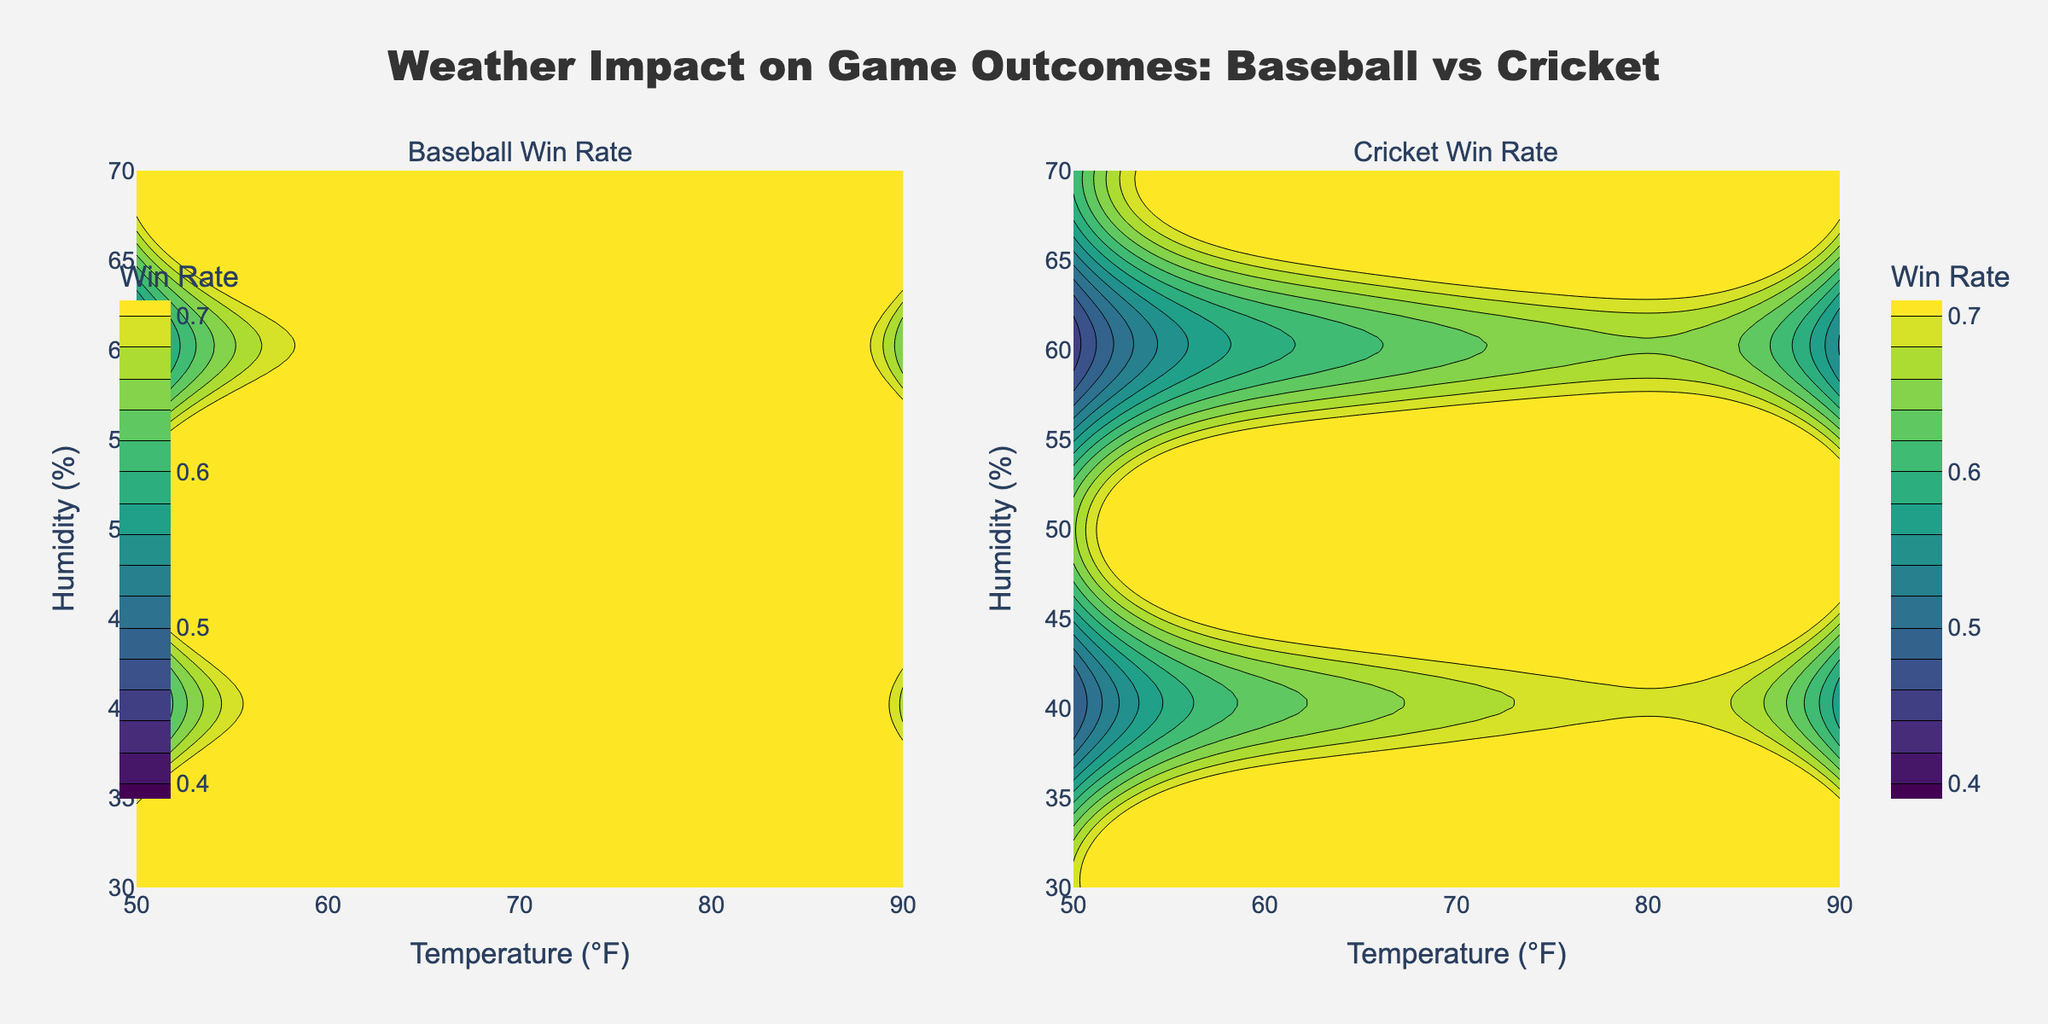What is the title of the figure? The title is usually displayed prominently at the top of the figure and provides a summary of what the figure is about. Here, it reads "Weather Impact on Game Outcomes: Baseball vs Cricket".
Answer: Weather Impact on Game Outcomes: Baseball vs Cricket What does the x-axis represent? The x-axis is labeled "Temperature (°F)", which indicates that the horizontal axis represents temperature measured in degrees Fahrenheit.
Answer: Temperature (°F) What does the y-axis represent? The y-axis is labeled "Humidity (%)", which means the vertical axis represents humidity as a percentage.
Answer: Humidity (%) Which type of plot is used to display the win rates for baseball and cricket? Both subplots use contour plots, which are used to represent three-dimensional data in two dimensions with contour lines.
Answer: Contour plots Which sport has a higher win rate at 90°F and 30% humidity? By finding the intersection of 90°F (x-axis) and 30% humidity (y-axis), we observe the win rates on both subplots. Baseball has a win rate of 0.68, while cricket has a win rate of 0.58.
Answer: Baseball At what temperature and humidity condition do baseball and cricket have almost the same win rate? By examining the contour lines, we find that around 70°F and 70% humidity, both sports have win rates close to 0.58 for baseball and 0.48 for cricket. However, they are closest in win rates around these conditions.
Answer: Around 70°F and 70% Which sport shows a more significant impact from increasing temperature? By observing the contour lines, baseball win rates increase more steeply with rising temperature compared to cricket, indicating a more noticeable impact.
Answer: Baseball How does humidity affect the win rates for cricket compared to baseball? The contours show cricket win rates decrease more noticeably with increasing humidity compared to baseball.
Answer: More negatively for cricket What is the win rate range shown in the contour color bar for baseball? The contour color bar for baseball ranges from 0.4 to 0.7, as indicated by the bar labels.
Answer: 0.4 to 0.7 Based on the figure, which weather condition seems to be optimal for baseball win rates? The highest win rate for baseball appears at 90°F and 30% humidity with a win rate of 0.68.
Answer: 90°F, 30% humidity 